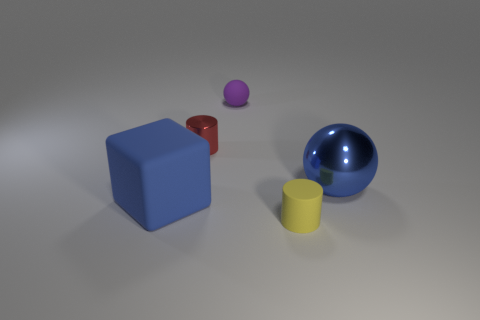Subtract all cyan cubes. Subtract all red spheres. How many cubes are left? 1 Add 2 rubber spheres. How many objects exist? 7 Subtract all cylinders. How many objects are left? 3 Add 4 red shiny cylinders. How many red shiny cylinders exist? 5 Subtract 0 brown cubes. How many objects are left? 5 Subtract all tiny yellow objects. Subtract all rubber objects. How many objects are left? 1 Add 1 tiny purple matte spheres. How many tiny purple matte spheres are left? 2 